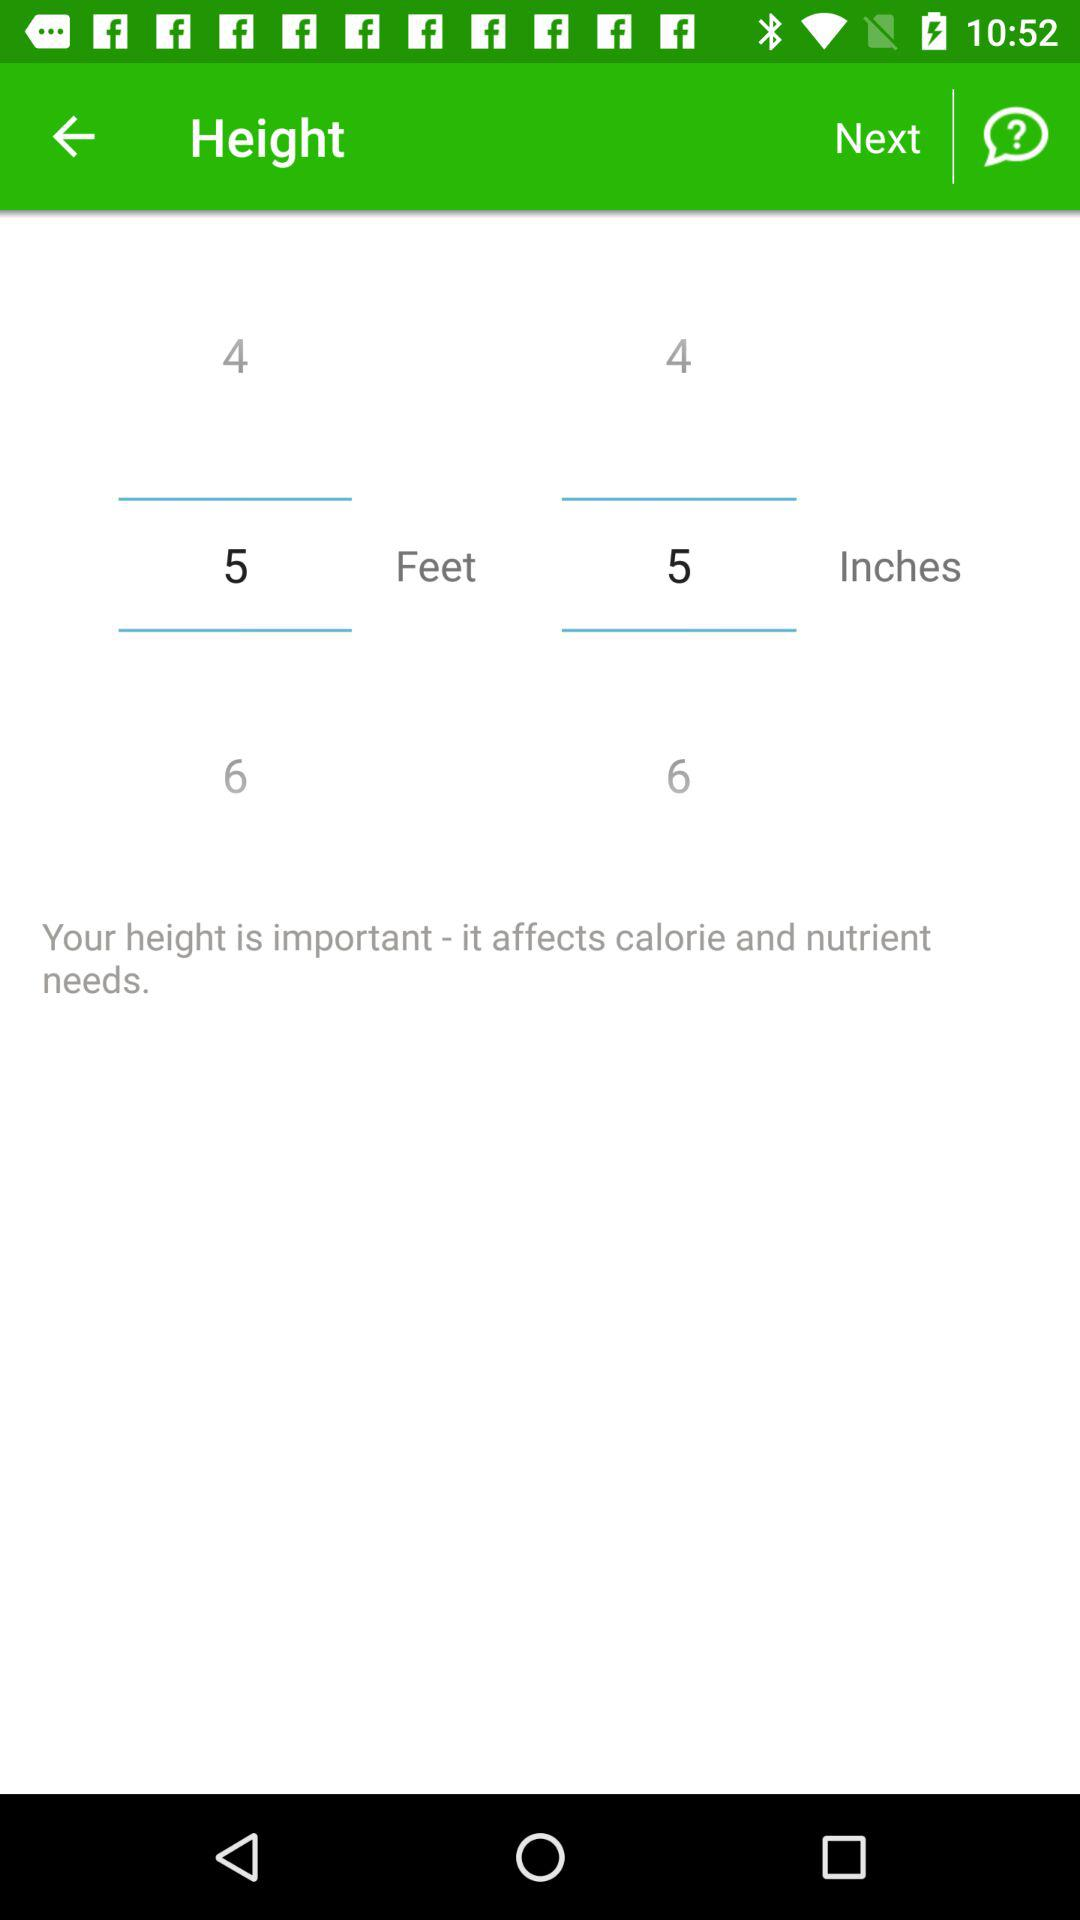Which height is selected? The selected height is 5 feet 5 inches. 